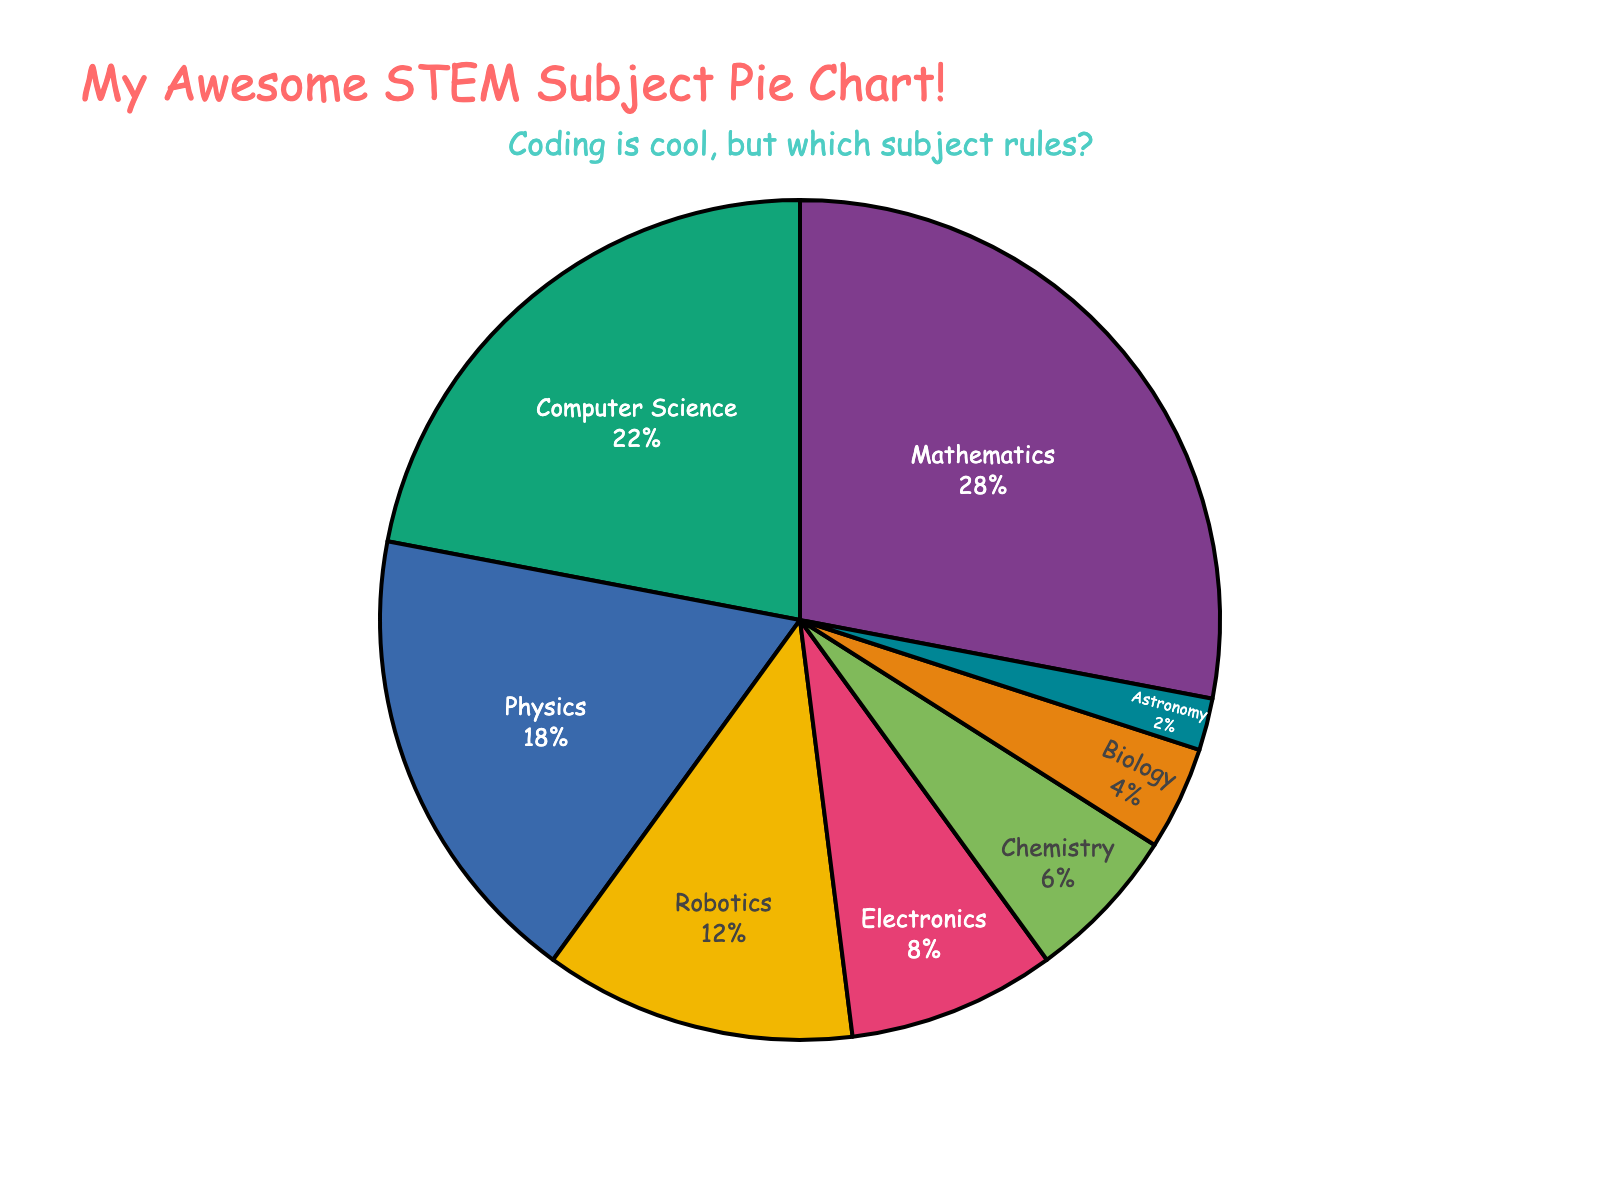what percentage of the young programmers prefer Physics over Chemistry? From the pie chart, Physics is 18% and Chemistry is 6%. Subtraction gives 18 - 6 = 12%. So, 12% more young programmers prefer Physics over Chemistry
Answer: 12% which subject has the second highest percentage, and what is that percentage? The subject with the highest percentage is Mathematics at 28%, so the second highest is Computer Science with 22%
Answer: Computer Science, 22% how many subjects have a percentage greater than or equal to 10%? From the pie chart, the subjects with percentages greater than or equal to 10% are Mathematics (28%), Computer Science (22%), Physics (18%), and Robotics (12%). Count of these subjects is 4
Answer: 4 compare the total percentage of subjects related to building (Robotics and Electronics) with Computer Science. Which is higher? Sum the percentages of Robotics (12%) and Electronics (8%) to get 12 + 8 = 20%, which is less than Computer Science (22%). Hence, Computer Science is higher
Answer: Computer Science is higher what is the combined percentage of the least preferred three subjects? The least preferred three subjects are Astronomy (2%), Biology (4%), and Chemistry (6%). Combined percentage is 2 + 4 + 6 = 12%
Answer: 12% identify the color associated with Mathematics on the pie chart. The pie chart uses a colorful palette; Mathematics slice often uses bright, bold colors like red, blue, or green for distinction. Based on this, identify the color used for Mathematics which stands out
Answer: (Color of Mathematics slice as per chart) is the percentage of Electronics more than half of Physics? The Electronics percentage is 8%, and half of Physics (which is 18%) is 9. 8% is less than 9%, so Electronics is less than half of Physics
Answer: No 